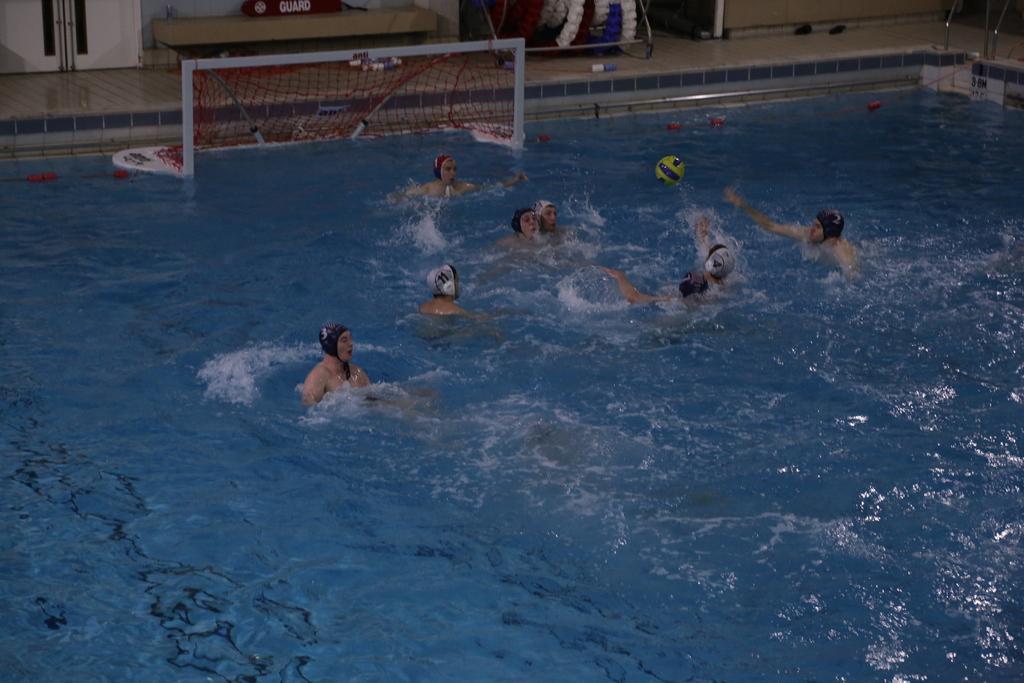Describe this image in one or two sentences. There is a group of people are playing in a swimming pool as we can see in the middle of this image. We can see a net and other objects in the background. 